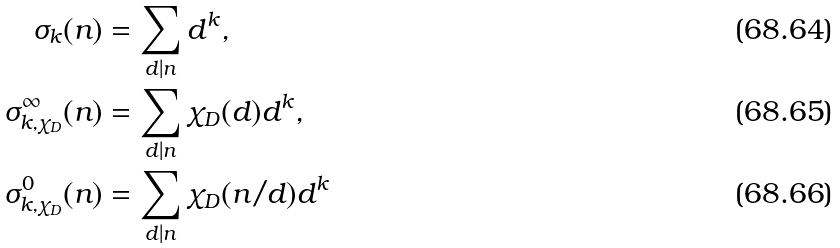Convert formula to latex. <formula><loc_0><loc_0><loc_500><loc_500>\sigma _ { k } ( n ) & = \sum _ { d | n } d ^ { k } , \\ \sigma _ { k , \chi _ { D } } ^ { \infty } ( n ) & = \sum _ { d | n } \chi _ { D } ( d ) d ^ { k } , \\ \sigma _ { k , \chi _ { D } } ^ { 0 } ( n ) & = \sum _ { d | n } \chi _ { D } ( n / d ) d ^ { k }</formula> 